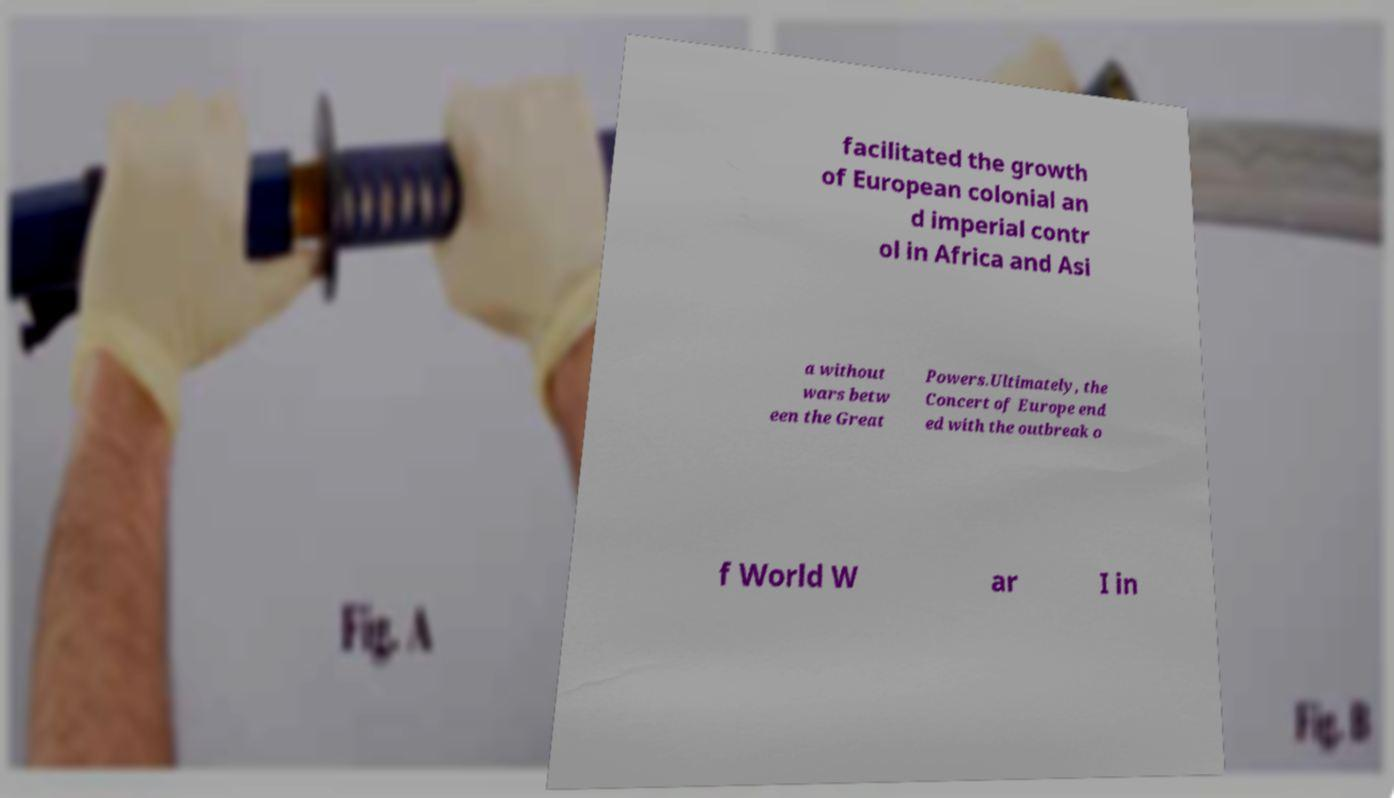Can you read and provide the text displayed in the image?This photo seems to have some interesting text. Can you extract and type it out for me? facilitated the growth of European colonial an d imperial contr ol in Africa and Asi a without wars betw een the Great Powers.Ultimately, the Concert of Europe end ed with the outbreak o f World W ar I in 